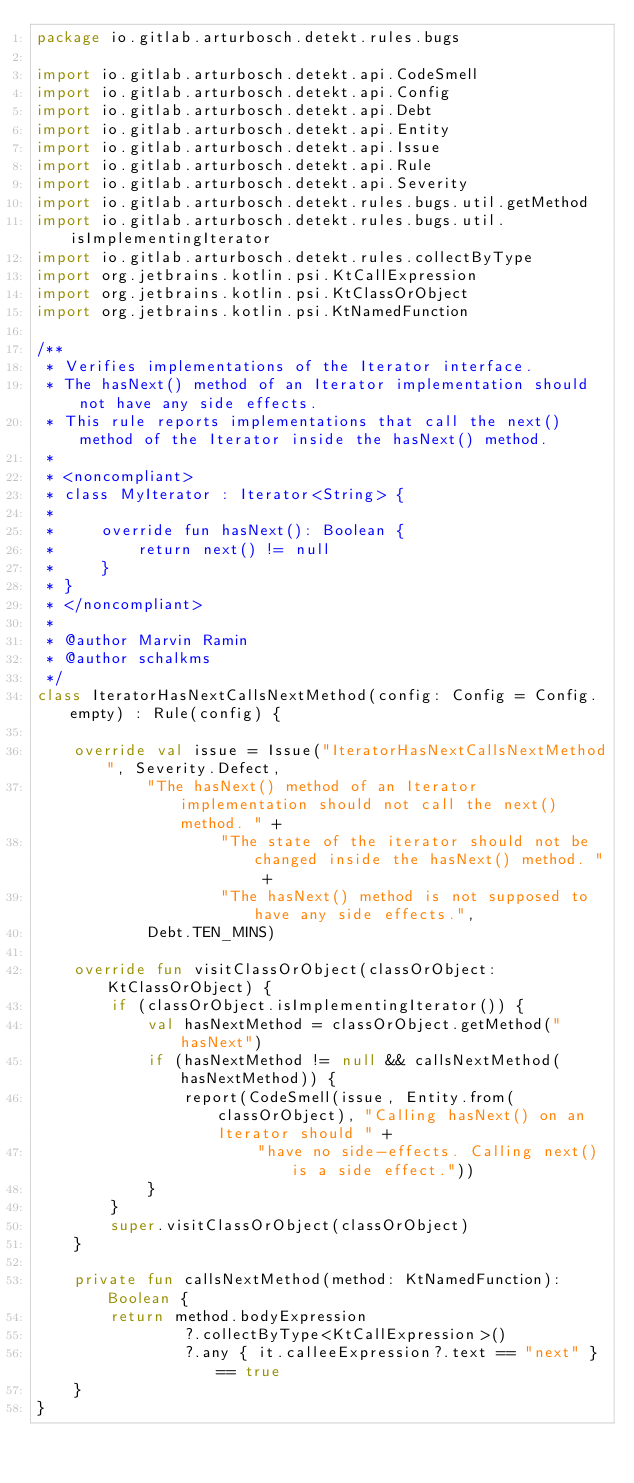<code> <loc_0><loc_0><loc_500><loc_500><_Kotlin_>package io.gitlab.arturbosch.detekt.rules.bugs

import io.gitlab.arturbosch.detekt.api.CodeSmell
import io.gitlab.arturbosch.detekt.api.Config
import io.gitlab.arturbosch.detekt.api.Debt
import io.gitlab.arturbosch.detekt.api.Entity
import io.gitlab.arturbosch.detekt.api.Issue
import io.gitlab.arturbosch.detekt.api.Rule
import io.gitlab.arturbosch.detekt.api.Severity
import io.gitlab.arturbosch.detekt.rules.bugs.util.getMethod
import io.gitlab.arturbosch.detekt.rules.bugs.util.isImplementingIterator
import io.gitlab.arturbosch.detekt.rules.collectByType
import org.jetbrains.kotlin.psi.KtCallExpression
import org.jetbrains.kotlin.psi.KtClassOrObject
import org.jetbrains.kotlin.psi.KtNamedFunction

/**
 * Verifies implementations of the Iterator interface.
 * The hasNext() method of an Iterator implementation should not have any side effects.
 * This rule reports implementations that call the next() method of the Iterator inside the hasNext() method.
 *
 * <noncompliant>
 * class MyIterator : Iterator<String> {
 *
 *     override fun hasNext(): Boolean {
 *         return next() != null
 *     }
 * }
 * </noncompliant>
 *
 * @author Marvin Ramin
 * @author schalkms
 */
class IteratorHasNextCallsNextMethod(config: Config = Config.empty) : Rule(config) {

	override val issue = Issue("IteratorHasNextCallsNextMethod", Severity.Defect,
			"The hasNext() method of an Iterator implementation should not call the next() method. " +
					"The state of the iterator should not be changed inside the hasNext() method. " +
					"The hasNext() method is not supposed to have any side effects.",
			Debt.TEN_MINS)

	override fun visitClassOrObject(classOrObject: KtClassOrObject) {
		if (classOrObject.isImplementingIterator()) {
			val hasNextMethod = classOrObject.getMethod("hasNext")
			if (hasNextMethod != null && callsNextMethod(hasNextMethod)) {
				report(CodeSmell(issue, Entity.from(classOrObject), "Calling hasNext() on an Iterator should " +
						"have no side-effects. Calling next() is a side effect."))
			}
		}
		super.visitClassOrObject(classOrObject)
	}

	private fun callsNextMethod(method: KtNamedFunction): Boolean {
		return method.bodyExpression
				?.collectByType<KtCallExpression>()
				?.any { it.calleeExpression?.text == "next" } == true
	}
}
</code> 